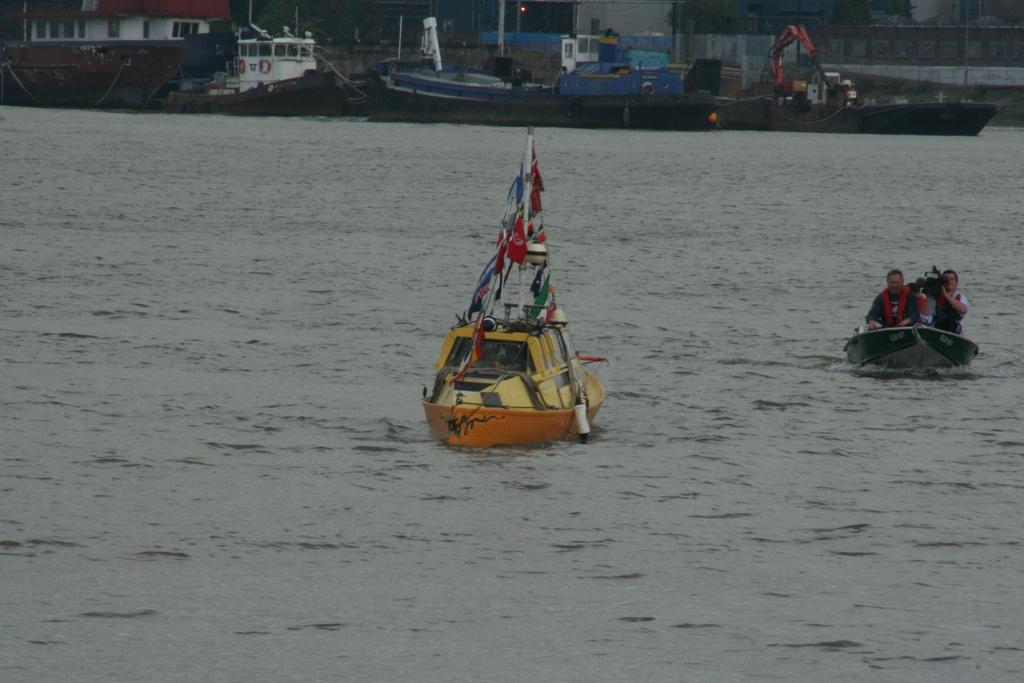What is the primary element in the image? There is water in the image. What types of objects are floating on the water? There are boats in the image. Are there any symbols or identifiers on the boats? Yes, there are flags in the image. What else can be seen in the image besides the boats and water? There are people and buildings in the background of the image. Can any vehicles be seen in the image? Yes, there is a vehicle in the background of the image. Can you see a frog using a blade to look at the water in the image? There is no frog or blade present in the image. 